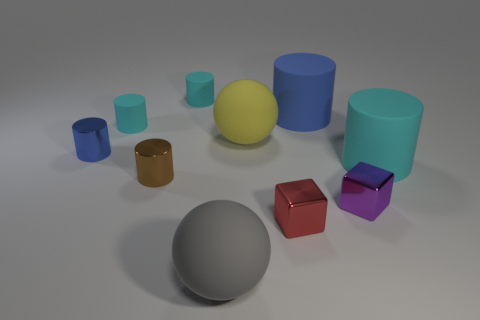What can you tell me about the shapes and the arrangement of the objects? The objects consist of geometric shapes such as spheres, cubes, and cylinders, which are arranged seemingly at random but with sufficient space between them to distinguish each object clearly. This arrangement gives the composition a sense of balance and variety, likely meant for an exercise in perspective and shading. 